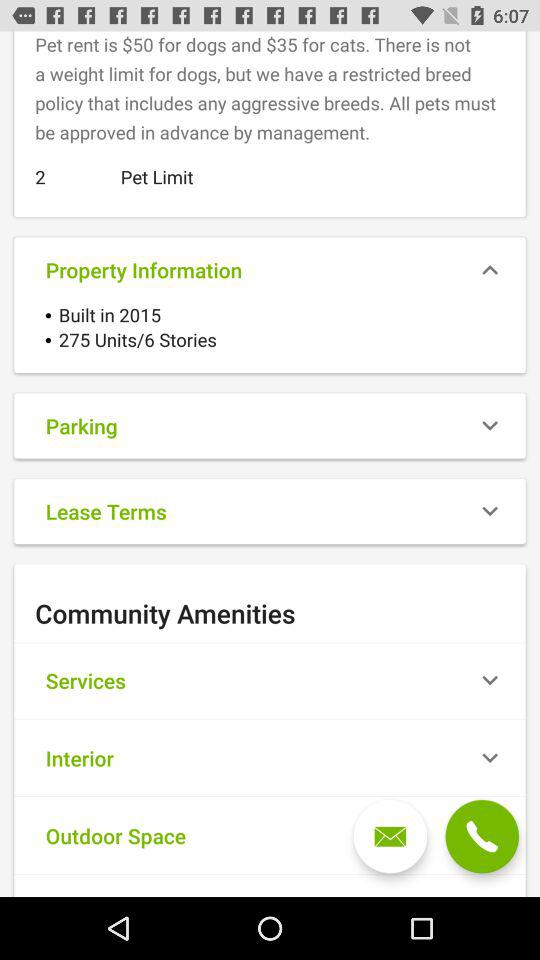When was the property built? The property was built in 2015. 